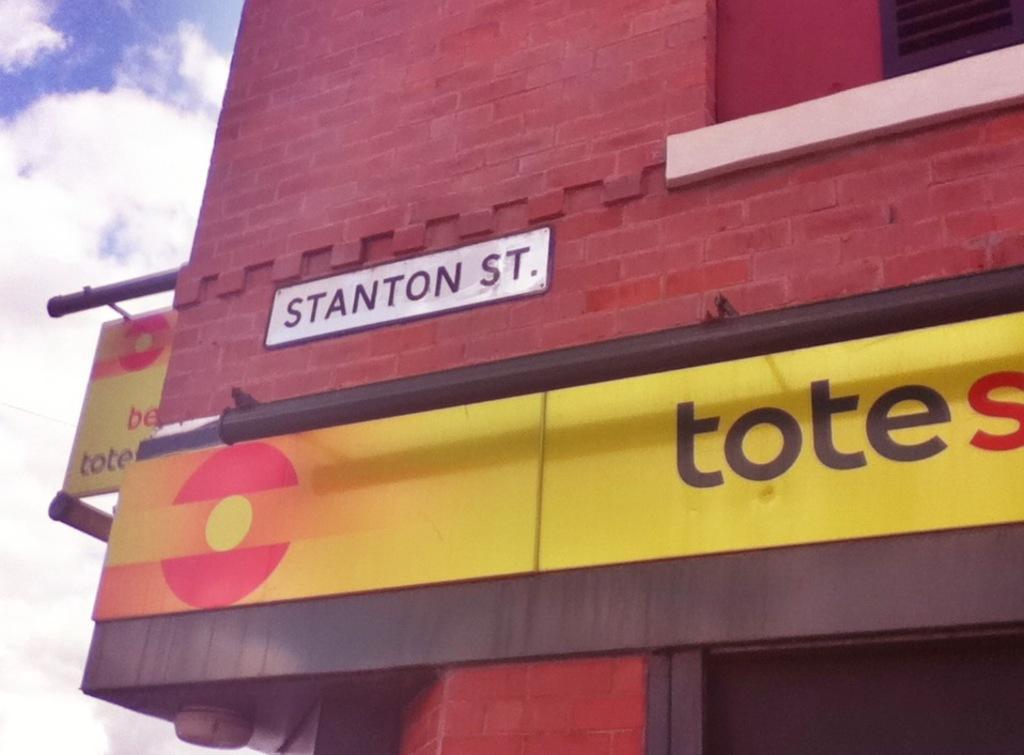Could you give a brief overview of what you see in this image? In this picture we can see few hoardings on the building and we can see clouds. 